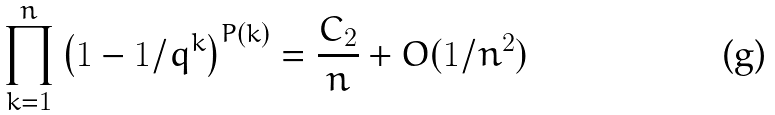<formula> <loc_0><loc_0><loc_500><loc_500>\prod _ { k = 1 } ^ { n } \left ( 1 - 1 / q ^ { k } \right ) ^ { P ( k ) } = \frac { C _ { 2 } } { n } + O ( 1 / n ^ { 2 } )</formula> 